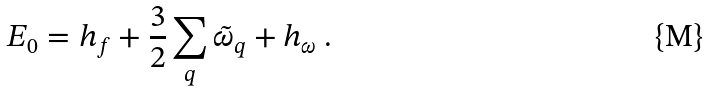<formula> <loc_0><loc_0><loc_500><loc_500>E _ { 0 } = h _ { f } + \frac { 3 } { 2 } \sum _ { q } \tilde { \omega } _ { q } + h _ { \omega } \ .</formula> 